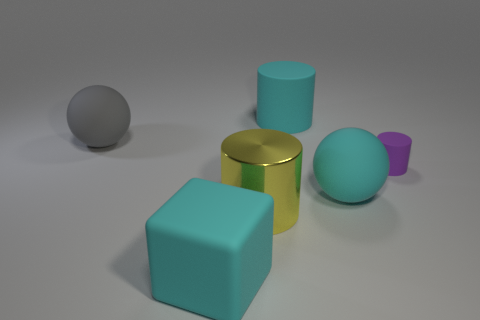Subtract all blue balls. Subtract all gray cylinders. How many balls are left? 2 Add 1 large matte blocks. How many objects exist? 7 Subtract all cubes. How many objects are left? 5 Add 4 large things. How many large things are left? 9 Add 3 shiny things. How many shiny things exist? 4 Subtract 0 green cubes. How many objects are left? 6 Subtract all blue rubber cylinders. Subtract all yellow things. How many objects are left? 5 